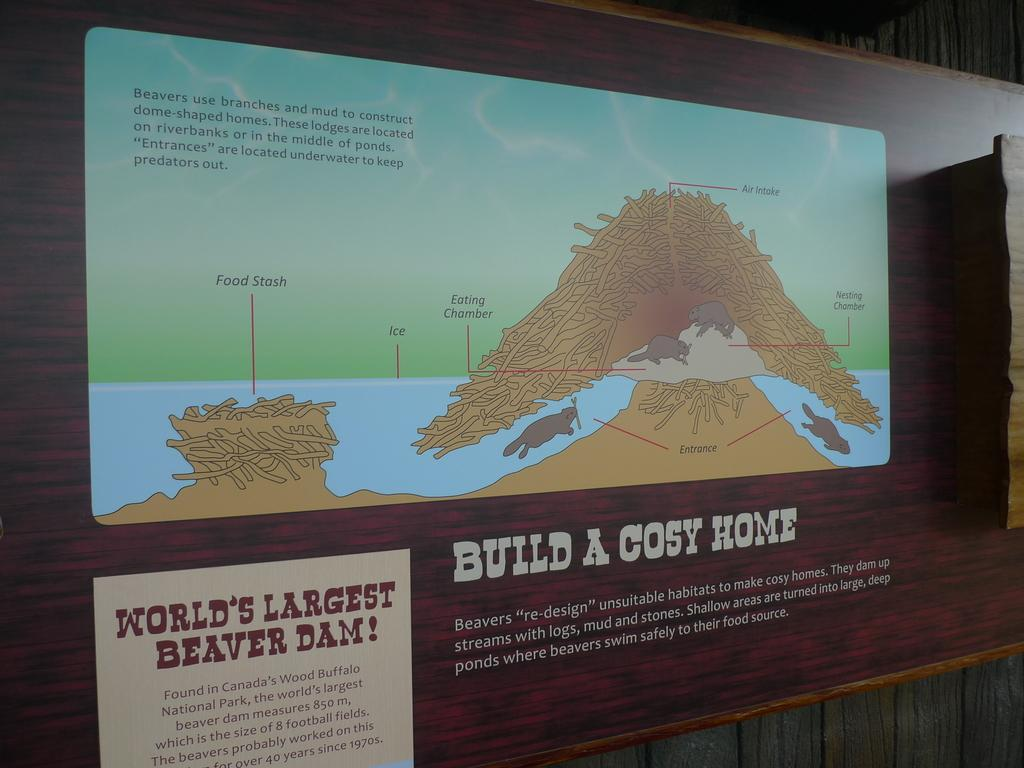<image>
Relay a brief, clear account of the picture shown. Worlds largest beaver damn sign from what is likely a park or zoo. 